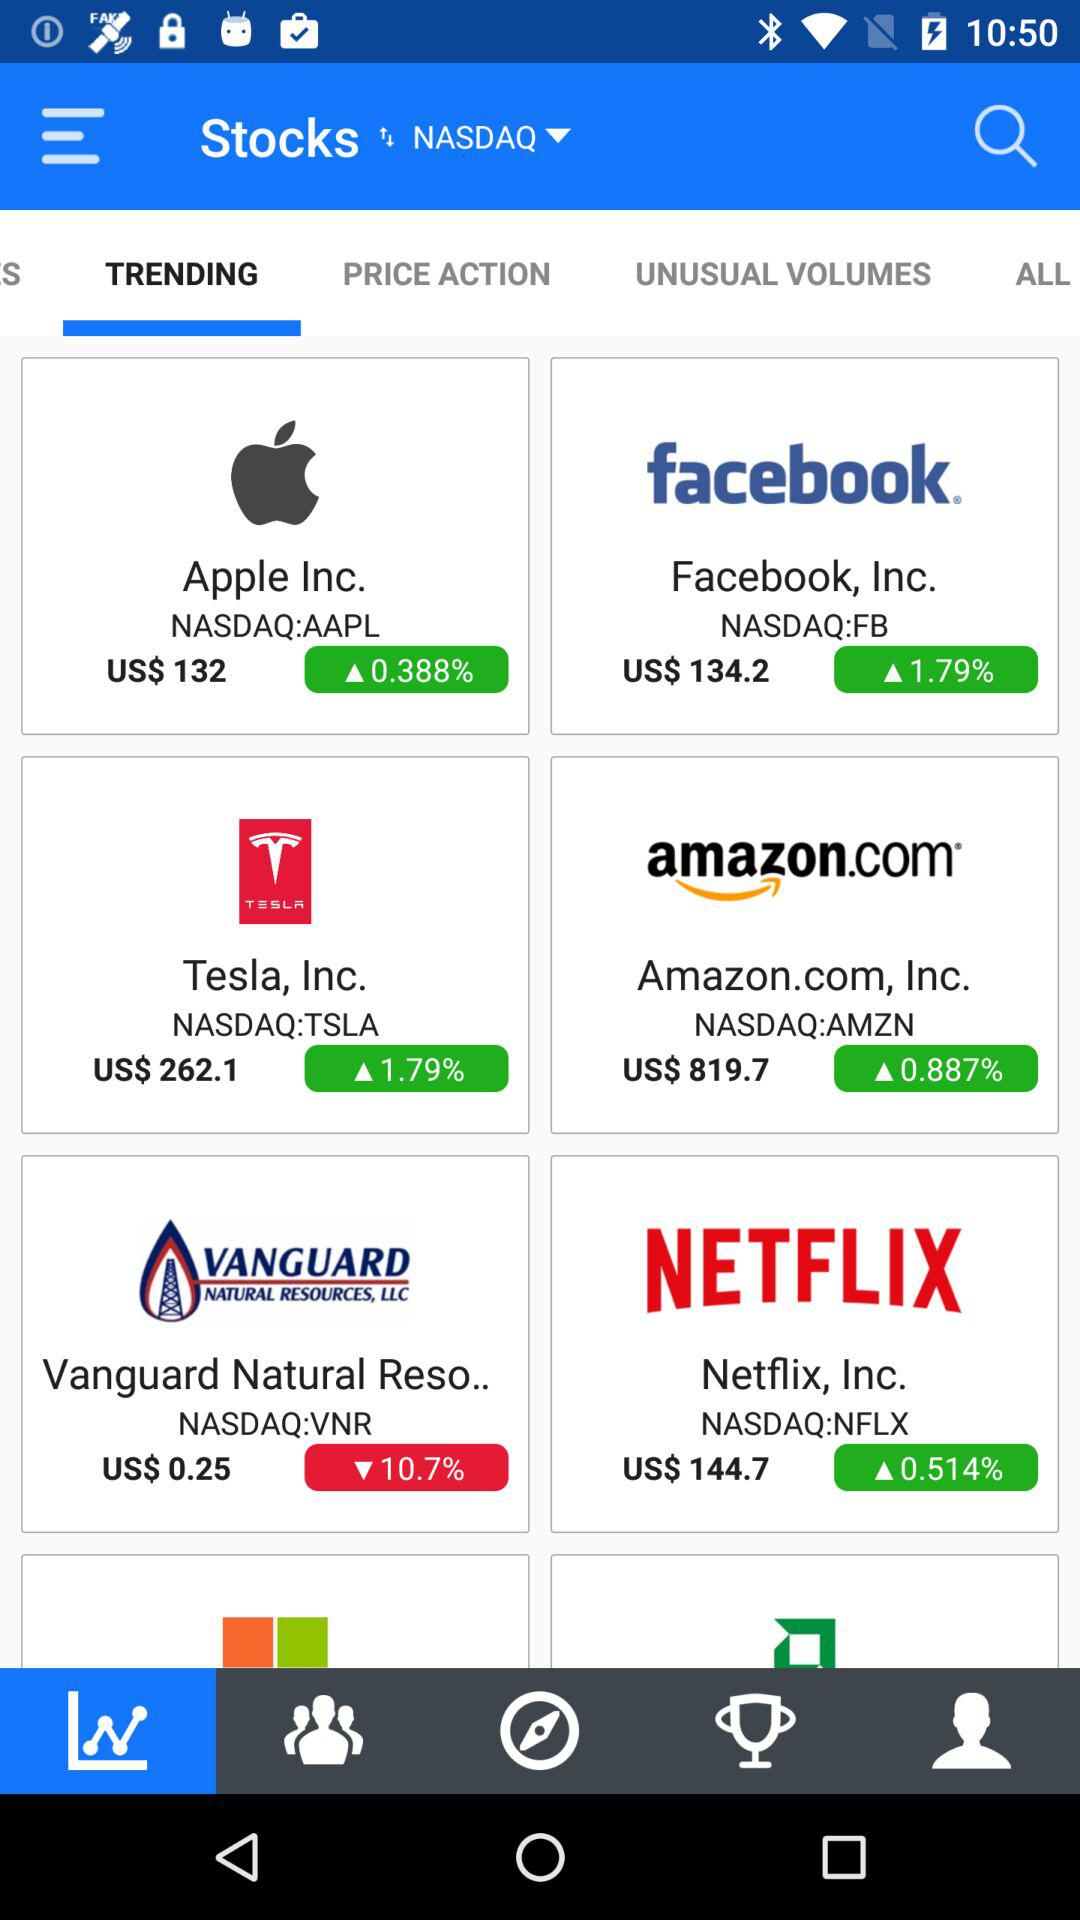How much is "Apple" stock worth? The stock of "Apple" is worth US$132. 